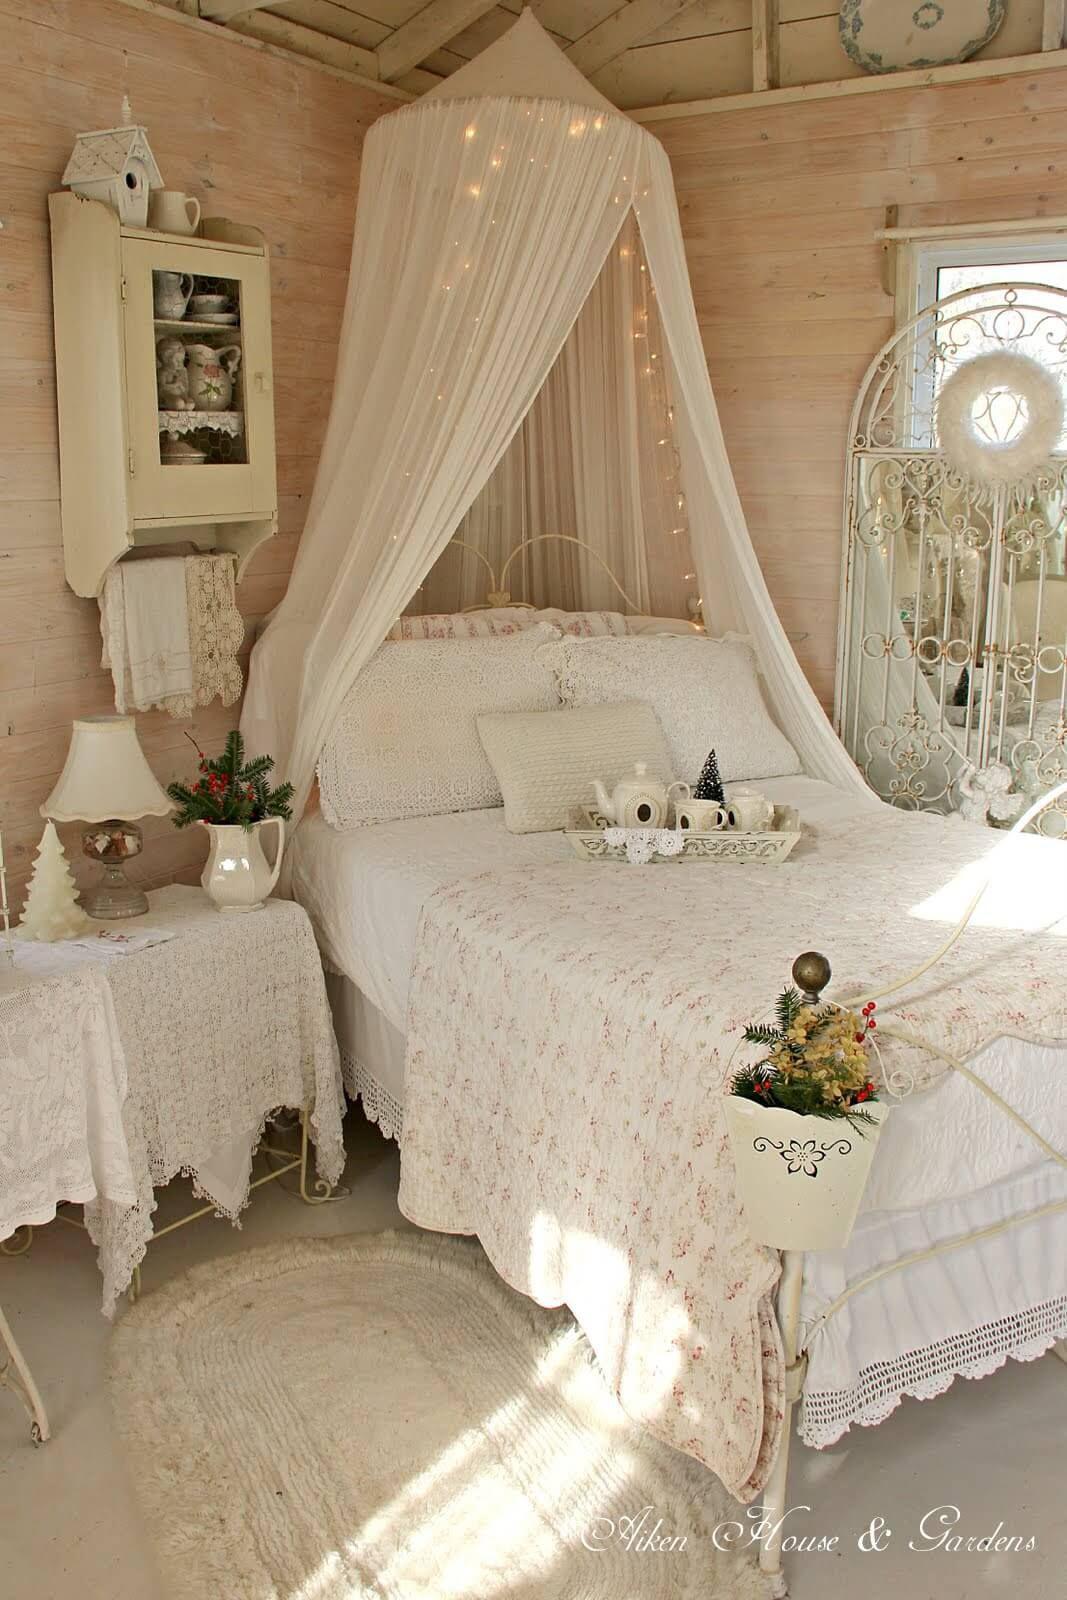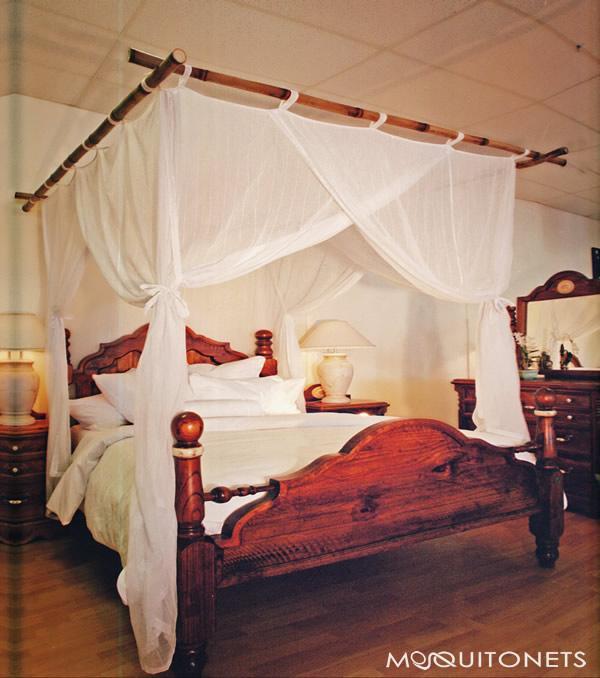The first image is the image on the left, the second image is the image on the right. Considering the images on both sides, is "There are two circle canopies." valid? Answer yes or no. No. The first image is the image on the left, the second image is the image on the right. Examine the images to the left and right. Is the description "There are two round canopies." accurate? Answer yes or no. No. 